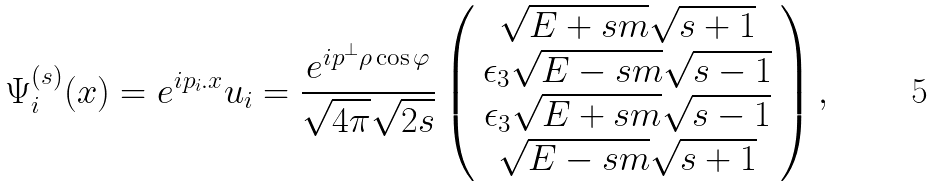<formula> <loc_0><loc_0><loc_500><loc_500>\Psi ^ { ( s ) } _ { i } ( x ) = e ^ { i p _ { i } . x } u _ { i } = \frac { e ^ { i p ^ { \bot } \rho \cos \varphi } } { \sqrt { 4 \pi } \sqrt { 2 s } } \left ( \begin{array} { c } \sqrt { E + s m } \sqrt { s + 1 } \\ \epsilon _ { 3 } \sqrt { E - s m } \sqrt { s - 1 } \\ \epsilon _ { 3 } \sqrt { E + s m } \sqrt { s - 1 } \\ \sqrt { E - s m } \sqrt { s + 1 } \end{array} \right ) ,</formula> 